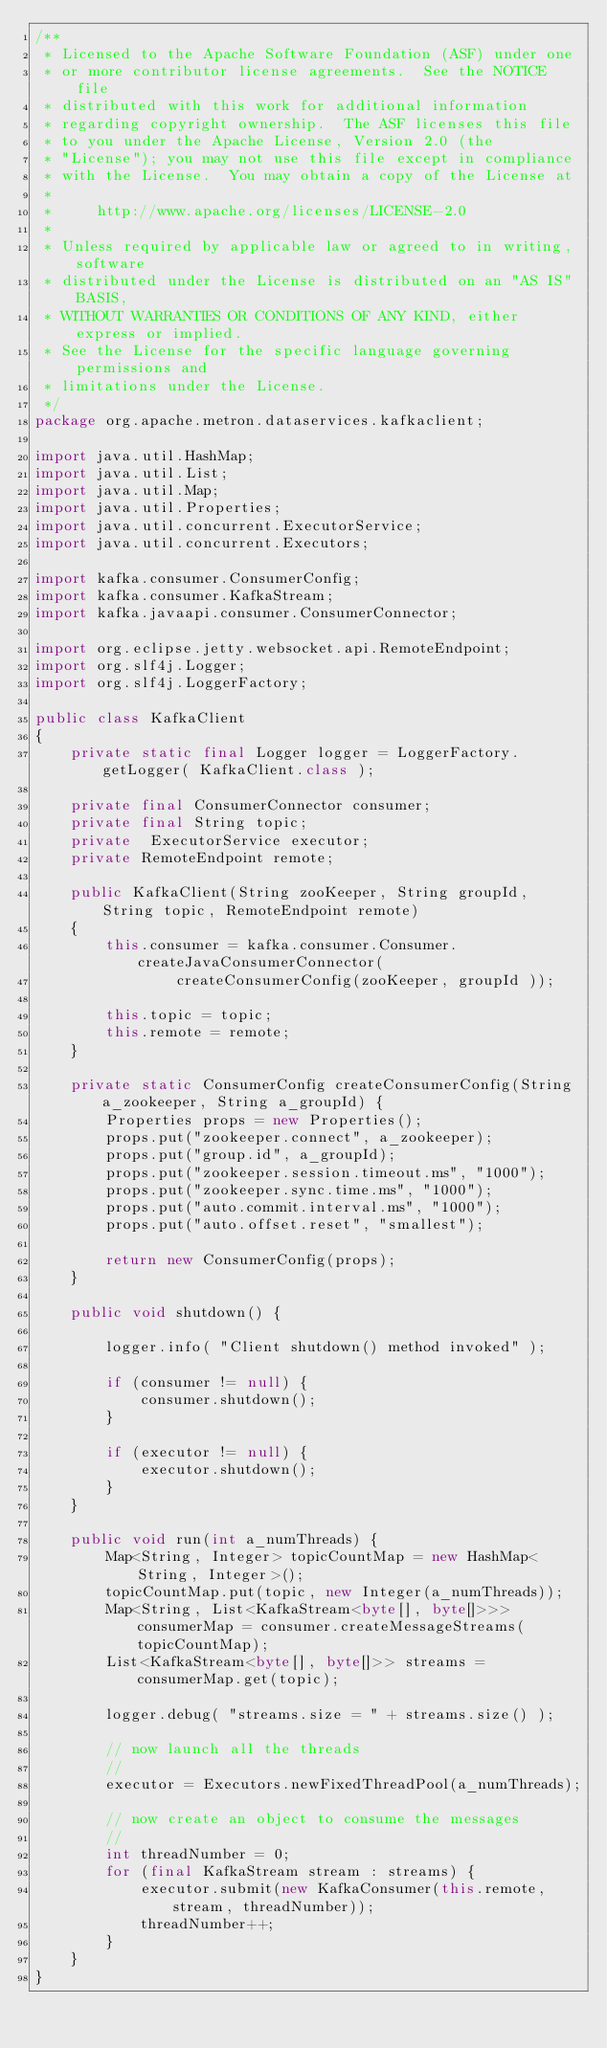<code> <loc_0><loc_0><loc_500><loc_500><_Java_>/**
 * Licensed to the Apache Software Foundation (ASF) under one
 * or more contributor license agreements.  See the NOTICE file
 * distributed with this work for additional information
 * regarding copyright ownership.  The ASF licenses this file
 * to you under the Apache License, Version 2.0 (the
 * "License"); you may not use this file except in compliance
 * with the License.  You may obtain a copy of the License at
 *
 *     http://www.apache.org/licenses/LICENSE-2.0
 *
 * Unless required by applicable law or agreed to in writing, software
 * distributed under the License is distributed on an "AS IS" BASIS,
 * WITHOUT WARRANTIES OR CONDITIONS OF ANY KIND, either express or implied.
 * See the License for the specific language governing permissions and
 * limitations under the License.
 */
package org.apache.metron.dataservices.kafkaclient;

import java.util.HashMap;
import java.util.List;
import java.util.Map;
import java.util.Properties;
import java.util.concurrent.ExecutorService;
import java.util.concurrent.Executors;

import kafka.consumer.ConsumerConfig;
import kafka.consumer.KafkaStream;
import kafka.javaapi.consumer.ConsumerConnector;

import org.eclipse.jetty.websocket.api.RemoteEndpoint;
import org.slf4j.Logger;
import org.slf4j.LoggerFactory;

public class KafkaClient 
{
	private static final Logger logger = LoggerFactory.getLogger( KafkaClient.class );
	
	private final ConsumerConnector consumer;
    private final String topic;
    private  ExecutorService executor;	
	private RemoteEndpoint remote;
       
    public KafkaClient(String zooKeeper, String groupId, String topic, RemoteEndpoint remote) 
    {
        this.consumer = kafka.consumer.Consumer.createJavaConsumerConnector(
                createConsumerConfig(zooKeeper, groupId ));
        
        this.topic = topic;
        this.remote = remote;
	}

	private static ConsumerConfig createConsumerConfig(String a_zookeeper, String a_groupId) {
        Properties props = new Properties();
        props.put("zookeeper.connect", a_zookeeper);
        props.put("group.id", a_groupId);
        props.put("zookeeper.session.timeout.ms", "1000");
        props.put("zookeeper.sync.time.ms", "1000");
        props.put("auto.commit.interval.ms", "1000");
        props.put("auto.offset.reset", "smallest");
        
        return new ConsumerConfig(props);
    }    
    
    public void shutdown() {
    	
    	logger.info( "Client shutdown() method invoked" );
    	
        if (consumer != null) { 
        	consumer.shutdown();
        }
        
        if (executor != null) { 
        	executor.shutdown(); 
        }
    }    
    
    public void run(int a_numThreads) {
        Map<String, Integer> topicCountMap = new HashMap<String, Integer>();
        topicCountMap.put(topic, new Integer(a_numThreads));
        Map<String, List<KafkaStream<byte[], byte[]>>> consumerMap = consumer.createMessageStreams(topicCountMap);
        List<KafkaStream<byte[], byte[]>> streams = consumerMap.get(topic);
 
        logger.debug( "streams.size = " + streams.size() );
        
        // now launch all the threads
        //
        executor = Executors.newFixedThreadPool(a_numThreads);

        // now create an object to consume the messages
        //
        int threadNumber = 0;
        for (final KafkaStream stream : streams) {
            executor.submit(new KafkaConsumer(this.remote, stream, threadNumber));
            threadNumber++;
        }
    }   	
}
</code> 